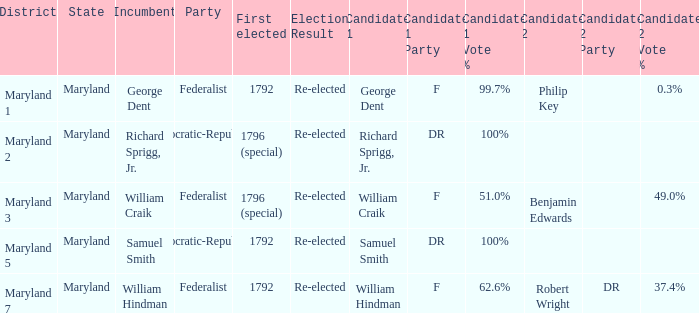0% and benjamin edwards at 4 Maryland 3. 